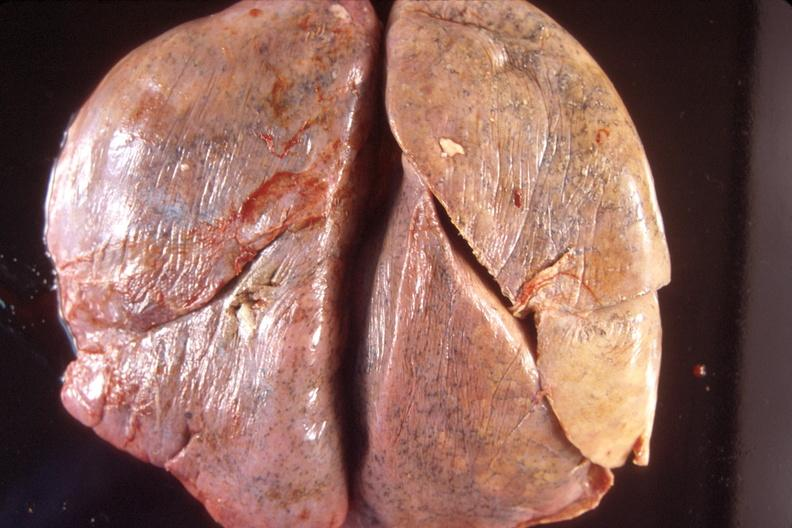s lymphangiomatosis generalized present?
Answer the question using a single word or phrase. No 